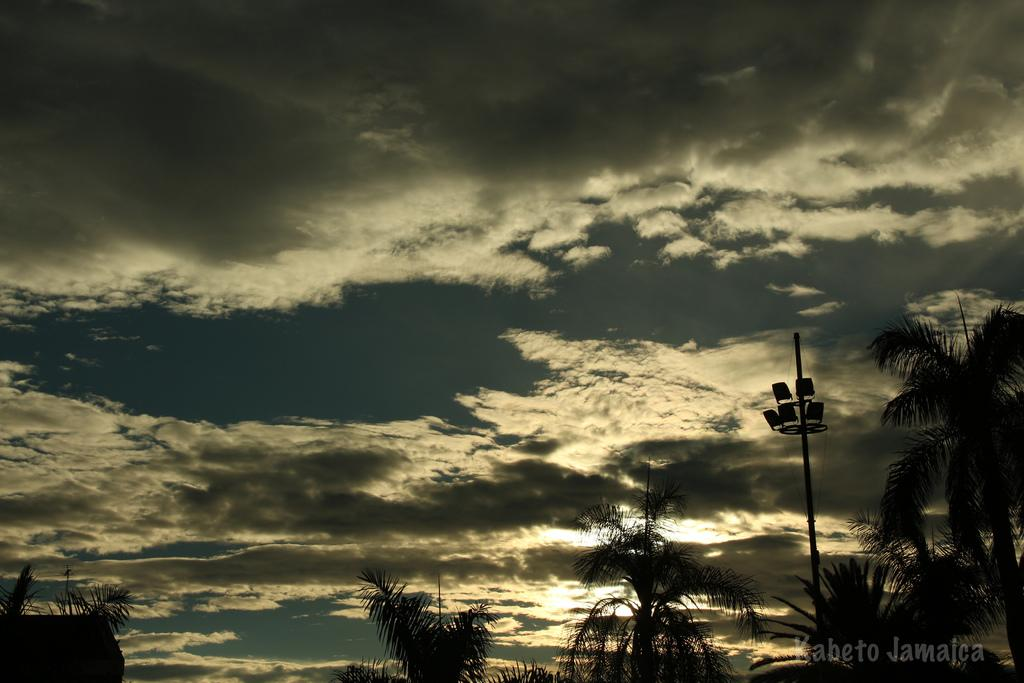What type of trees can be seen in the image? There are coconut trees in the image. What structure is present in the image that provides lighting? There is a pole with street lights in the image. How would you describe the appearance of the sky in the image? The sky appears dark and gloomy in the image. What direction is the quiver pointing in the image? There is no quiver present in the image. How does the north pole affect the weather in the image? The image does not show any influence from the north pole, and the weather is determined by the dark and gloomy sky. 